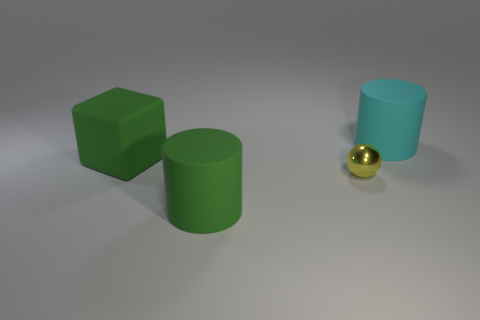What number of rubber things are yellow things or large green objects?
Your response must be concise. 2. Is the number of things that are right of the small yellow shiny sphere greater than the number of big things?
Provide a succinct answer. No. There is a cylinder behind the green rubber block; what is it made of?
Offer a very short reply. Rubber. How many green things are the same material as the green cylinder?
Your answer should be compact. 1. The thing that is to the right of the big green cylinder and behind the small yellow sphere has what shape?
Your response must be concise. Cylinder. What number of objects are either objects in front of the metallic object or green things that are in front of the small object?
Offer a very short reply. 1. Is the number of cyan rubber cylinders that are in front of the small yellow thing the same as the number of large cyan cylinders that are to the right of the rubber block?
Offer a very short reply. No. There is a tiny metal thing to the right of the big green object behind the green rubber cylinder; what shape is it?
Ensure brevity in your answer.  Sphere. Are there any other red metallic things that have the same shape as the metallic object?
Provide a short and direct response. No. What number of cyan objects are there?
Offer a very short reply. 1. 